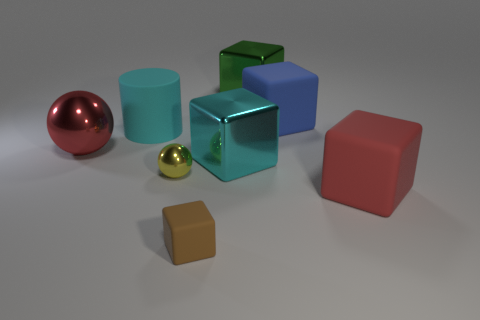Subtract all purple blocks. Subtract all purple spheres. How many blocks are left? 5 Add 2 small brown matte blocks. How many objects exist? 10 Subtract all cubes. How many objects are left? 3 Subtract 0 yellow cubes. How many objects are left? 8 Subtract all large yellow cylinders. Subtract all large cyan shiny cubes. How many objects are left? 7 Add 3 red metallic balls. How many red metallic balls are left? 4 Add 8 green objects. How many green objects exist? 9 